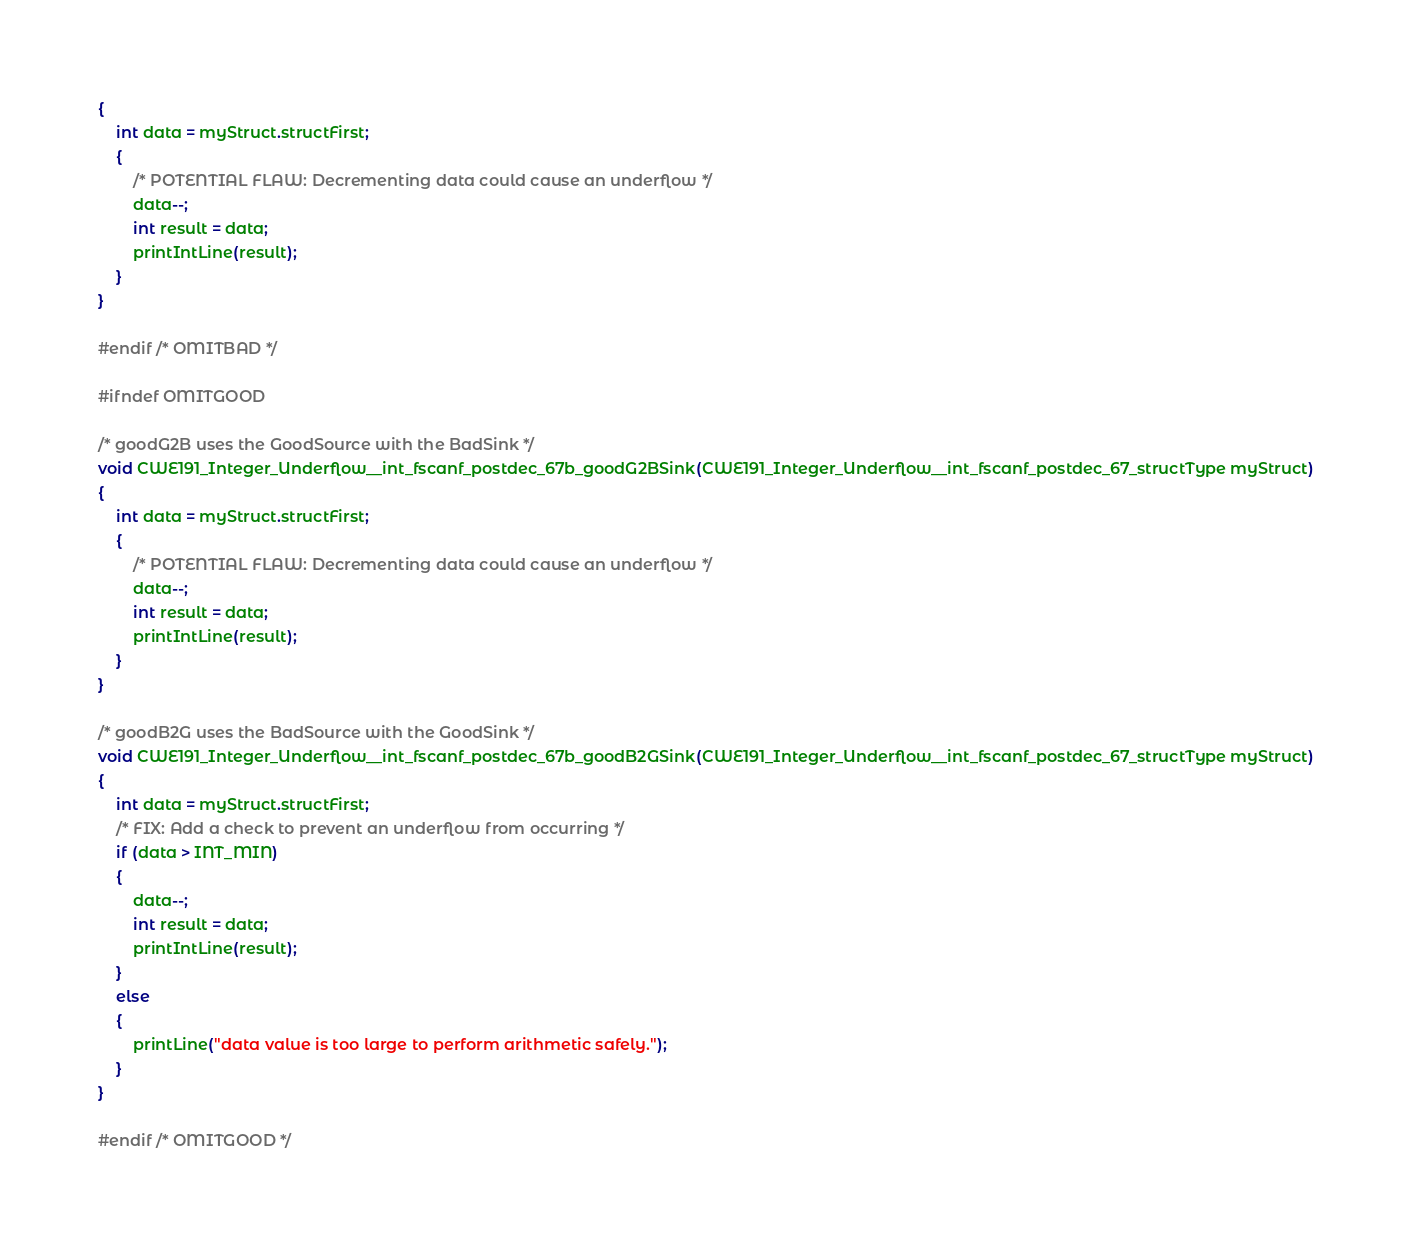<code> <loc_0><loc_0><loc_500><loc_500><_C_>{
    int data = myStruct.structFirst;
    {
        /* POTENTIAL FLAW: Decrementing data could cause an underflow */
        data--;
        int result = data;
        printIntLine(result);
    }
}

#endif /* OMITBAD */

#ifndef OMITGOOD

/* goodG2B uses the GoodSource with the BadSink */
void CWE191_Integer_Underflow__int_fscanf_postdec_67b_goodG2BSink(CWE191_Integer_Underflow__int_fscanf_postdec_67_structType myStruct)
{
    int data = myStruct.structFirst;
    {
        /* POTENTIAL FLAW: Decrementing data could cause an underflow */
        data--;
        int result = data;
        printIntLine(result);
    }
}

/* goodB2G uses the BadSource with the GoodSink */
void CWE191_Integer_Underflow__int_fscanf_postdec_67b_goodB2GSink(CWE191_Integer_Underflow__int_fscanf_postdec_67_structType myStruct)
{
    int data = myStruct.structFirst;
    /* FIX: Add a check to prevent an underflow from occurring */
    if (data > INT_MIN)
    {
        data--;
        int result = data;
        printIntLine(result);
    }
    else
    {
        printLine("data value is too large to perform arithmetic safely.");
    }
}

#endif /* OMITGOOD */
</code> 